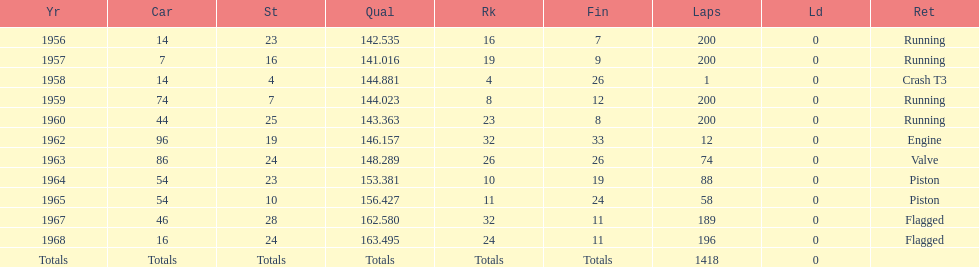Tell me the number of times he finished above 10th place. 3. 